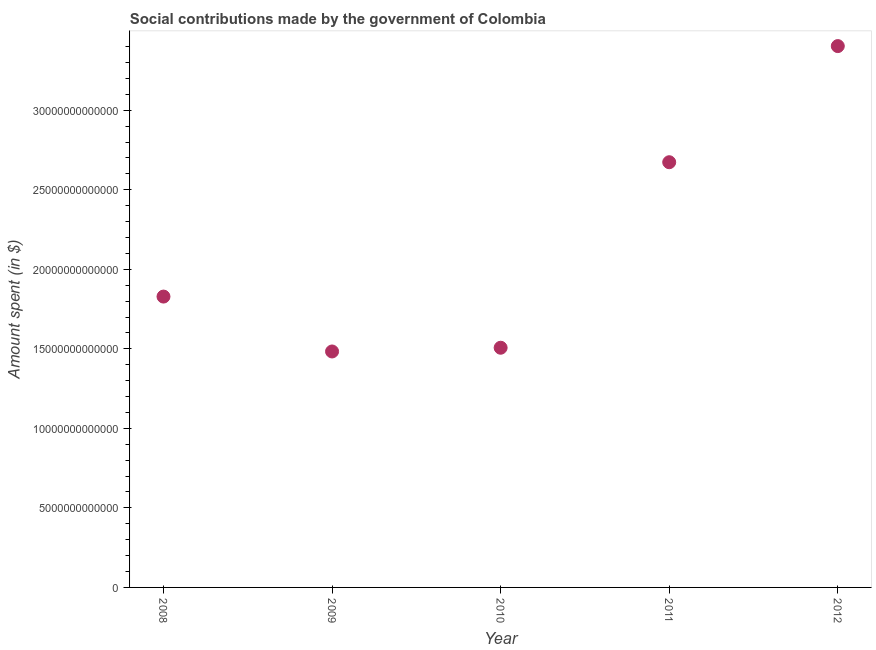What is the amount spent in making social contributions in 2008?
Keep it short and to the point. 1.83e+13. Across all years, what is the maximum amount spent in making social contributions?
Your answer should be very brief. 3.40e+13. Across all years, what is the minimum amount spent in making social contributions?
Offer a very short reply. 1.48e+13. What is the sum of the amount spent in making social contributions?
Your response must be concise. 1.09e+14. What is the difference between the amount spent in making social contributions in 2010 and 2011?
Your answer should be compact. -1.17e+13. What is the average amount spent in making social contributions per year?
Ensure brevity in your answer.  2.18e+13. What is the median amount spent in making social contributions?
Offer a very short reply. 1.83e+13. What is the ratio of the amount spent in making social contributions in 2009 to that in 2010?
Your answer should be very brief. 0.98. Is the amount spent in making social contributions in 2010 less than that in 2012?
Provide a short and direct response. Yes. Is the difference between the amount spent in making social contributions in 2009 and 2010 greater than the difference between any two years?
Offer a very short reply. No. What is the difference between the highest and the second highest amount spent in making social contributions?
Provide a succinct answer. 7.30e+12. Is the sum of the amount spent in making social contributions in 2009 and 2011 greater than the maximum amount spent in making social contributions across all years?
Offer a very short reply. Yes. What is the difference between the highest and the lowest amount spent in making social contributions?
Offer a very short reply. 1.92e+13. How many dotlines are there?
Offer a very short reply. 1. How many years are there in the graph?
Offer a terse response. 5. What is the difference between two consecutive major ticks on the Y-axis?
Keep it short and to the point. 5.00e+12. Are the values on the major ticks of Y-axis written in scientific E-notation?
Your response must be concise. No. Does the graph contain any zero values?
Offer a terse response. No. Does the graph contain grids?
Provide a short and direct response. No. What is the title of the graph?
Provide a short and direct response. Social contributions made by the government of Colombia. What is the label or title of the X-axis?
Your answer should be compact. Year. What is the label or title of the Y-axis?
Provide a short and direct response. Amount spent (in $). What is the Amount spent (in $) in 2008?
Keep it short and to the point. 1.83e+13. What is the Amount spent (in $) in 2009?
Offer a very short reply. 1.48e+13. What is the Amount spent (in $) in 2010?
Your answer should be very brief. 1.51e+13. What is the Amount spent (in $) in 2011?
Provide a succinct answer. 2.67e+13. What is the Amount spent (in $) in 2012?
Make the answer very short. 3.40e+13. What is the difference between the Amount spent (in $) in 2008 and 2009?
Make the answer very short. 3.45e+12. What is the difference between the Amount spent (in $) in 2008 and 2010?
Keep it short and to the point. 3.22e+12. What is the difference between the Amount spent (in $) in 2008 and 2011?
Provide a short and direct response. -8.45e+12. What is the difference between the Amount spent (in $) in 2008 and 2012?
Offer a very short reply. -1.57e+13. What is the difference between the Amount spent (in $) in 2009 and 2010?
Your answer should be very brief. -2.35e+11. What is the difference between the Amount spent (in $) in 2009 and 2011?
Ensure brevity in your answer.  -1.19e+13. What is the difference between the Amount spent (in $) in 2009 and 2012?
Offer a very short reply. -1.92e+13. What is the difference between the Amount spent (in $) in 2010 and 2011?
Offer a very short reply. -1.17e+13. What is the difference between the Amount spent (in $) in 2010 and 2012?
Offer a terse response. -1.90e+13. What is the difference between the Amount spent (in $) in 2011 and 2012?
Offer a very short reply. -7.30e+12. What is the ratio of the Amount spent (in $) in 2008 to that in 2009?
Ensure brevity in your answer.  1.23. What is the ratio of the Amount spent (in $) in 2008 to that in 2010?
Keep it short and to the point. 1.21. What is the ratio of the Amount spent (in $) in 2008 to that in 2011?
Make the answer very short. 0.68. What is the ratio of the Amount spent (in $) in 2008 to that in 2012?
Your answer should be compact. 0.54. What is the ratio of the Amount spent (in $) in 2009 to that in 2010?
Your response must be concise. 0.98. What is the ratio of the Amount spent (in $) in 2009 to that in 2011?
Offer a terse response. 0.56. What is the ratio of the Amount spent (in $) in 2009 to that in 2012?
Offer a very short reply. 0.44. What is the ratio of the Amount spent (in $) in 2010 to that in 2011?
Keep it short and to the point. 0.56. What is the ratio of the Amount spent (in $) in 2010 to that in 2012?
Ensure brevity in your answer.  0.44. What is the ratio of the Amount spent (in $) in 2011 to that in 2012?
Make the answer very short. 0.79. 